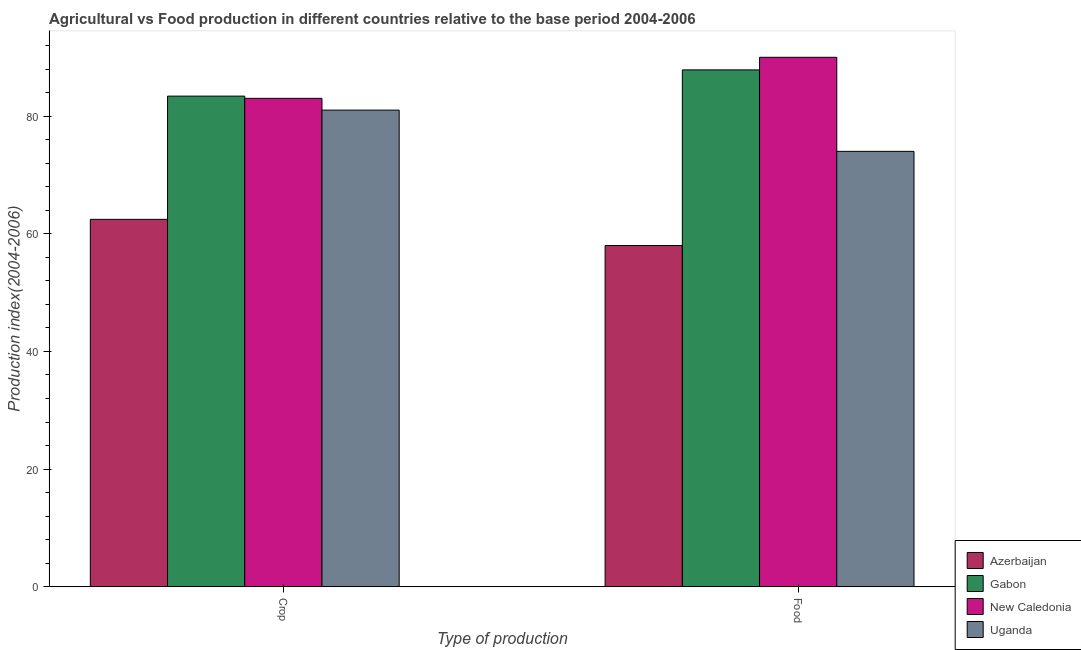What is the label of the 1st group of bars from the left?
Offer a very short reply. Crop. What is the crop production index in Azerbaijan?
Ensure brevity in your answer.  62.46. Across all countries, what is the maximum food production index?
Your answer should be compact. 90.01. Across all countries, what is the minimum crop production index?
Provide a succinct answer. 62.46. In which country was the crop production index maximum?
Provide a succinct answer. Gabon. In which country was the crop production index minimum?
Provide a succinct answer. Azerbaijan. What is the total crop production index in the graph?
Your answer should be very brief. 309.93. What is the difference between the crop production index in New Caledonia and that in Azerbaijan?
Your answer should be compact. 20.57. What is the difference between the crop production index in Azerbaijan and the food production index in Gabon?
Offer a very short reply. -25.41. What is the average food production index per country?
Your answer should be very brief. 77.48. What is the difference between the crop production index and food production index in New Caledonia?
Provide a short and direct response. -6.98. In how many countries, is the crop production index greater than 8 ?
Offer a terse response. 4. What is the ratio of the food production index in New Caledonia to that in Gabon?
Make the answer very short. 1.02. What does the 2nd bar from the left in Crop represents?
Make the answer very short. Gabon. What does the 1st bar from the right in Food represents?
Keep it short and to the point. Uganda. How many countries are there in the graph?
Offer a very short reply. 4. What is the difference between two consecutive major ticks on the Y-axis?
Offer a terse response. 20. Where does the legend appear in the graph?
Offer a terse response. Bottom right. What is the title of the graph?
Provide a short and direct response. Agricultural vs Food production in different countries relative to the base period 2004-2006. What is the label or title of the X-axis?
Offer a terse response. Type of production. What is the label or title of the Y-axis?
Offer a very short reply. Production index(2004-2006). What is the Production index(2004-2006) in Azerbaijan in Crop?
Make the answer very short. 62.46. What is the Production index(2004-2006) in Gabon in Crop?
Offer a terse response. 83.41. What is the Production index(2004-2006) of New Caledonia in Crop?
Your response must be concise. 83.03. What is the Production index(2004-2006) in Uganda in Crop?
Offer a terse response. 81.03. What is the Production index(2004-2006) of Azerbaijan in Food?
Keep it short and to the point. 58.01. What is the Production index(2004-2006) of Gabon in Food?
Offer a terse response. 87.87. What is the Production index(2004-2006) of New Caledonia in Food?
Keep it short and to the point. 90.01. What is the Production index(2004-2006) of Uganda in Food?
Make the answer very short. 74.02. Across all Type of production, what is the maximum Production index(2004-2006) of Azerbaijan?
Your response must be concise. 62.46. Across all Type of production, what is the maximum Production index(2004-2006) of Gabon?
Your answer should be compact. 87.87. Across all Type of production, what is the maximum Production index(2004-2006) of New Caledonia?
Provide a succinct answer. 90.01. Across all Type of production, what is the maximum Production index(2004-2006) of Uganda?
Provide a short and direct response. 81.03. Across all Type of production, what is the minimum Production index(2004-2006) in Azerbaijan?
Offer a terse response. 58.01. Across all Type of production, what is the minimum Production index(2004-2006) in Gabon?
Make the answer very short. 83.41. Across all Type of production, what is the minimum Production index(2004-2006) in New Caledonia?
Your answer should be compact. 83.03. Across all Type of production, what is the minimum Production index(2004-2006) in Uganda?
Your answer should be very brief. 74.02. What is the total Production index(2004-2006) of Azerbaijan in the graph?
Provide a succinct answer. 120.47. What is the total Production index(2004-2006) of Gabon in the graph?
Offer a very short reply. 171.28. What is the total Production index(2004-2006) of New Caledonia in the graph?
Provide a succinct answer. 173.04. What is the total Production index(2004-2006) in Uganda in the graph?
Your response must be concise. 155.05. What is the difference between the Production index(2004-2006) of Azerbaijan in Crop and that in Food?
Make the answer very short. 4.45. What is the difference between the Production index(2004-2006) in Gabon in Crop and that in Food?
Give a very brief answer. -4.46. What is the difference between the Production index(2004-2006) in New Caledonia in Crop and that in Food?
Your response must be concise. -6.98. What is the difference between the Production index(2004-2006) of Uganda in Crop and that in Food?
Your answer should be very brief. 7.01. What is the difference between the Production index(2004-2006) of Azerbaijan in Crop and the Production index(2004-2006) of Gabon in Food?
Give a very brief answer. -25.41. What is the difference between the Production index(2004-2006) of Azerbaijan in Crop and the Production index(2004-2006) of New Caledonia in Food?
Your response must be concise. -27.55. What is the difference between the Production index(2004-2006) of Azerbaijan in Crop and the Production index(2004-2006) of Uganda in Food?
Provide a succinct answer. -11.56. What is the difference between the Production index(2004-2006) of Gabon in Crop and the Production index(2004-2006) of New Caledonia in Food?
Your response must be concise. -6.6. What is the difference between the Production index(2004-2006) in Gabon in Crop and the Production index(2004-2006) in Uganda in Food?
Offer a terse response. 9.39. What is the difference between the Production index(2004-2006) in New Caledonia in Crop and the Production index(2004-2006) in Uganda in Food?
Ensure brevity in your answer.  9.01. What is the average Production index(2004-2006) in Azerbaijan per Type of production?
Ensure brevity in your answer.  60.23. What is the average Production index(2004-2006) in Gabon per Type of production?
Keep it short and to the point. 85.64. What is the average Production index(2004-2006) in New Caledonia per Type of production?
Provide a succinct answer. 86.52. What is the average Production index(2004-2006) of Uganda per Type of production?
Give a very brief answer. 77.53. What is the difference between the Production index(2004-2006) in Azerbaijan and Production index(2004-2006) in Gabon in Crop?
Offer a very short reply. -20.95. What is the difference between the Production index(2004-2006) of Azerbaijan and Production index(2004-2006) of New Caledonia in Crop?
Your answer should be compact. -20.57. What is the difference between the Production index(2004-2006) of Azerbaijan and Production index(2004-2006) of Uganda in Crop?
Your answer should be very brief. -18.57. What is the difference between the Production index(2004-2006) of Gabon and Production index(2004-2006) of New Caledonia in Crop?
Offer a very short reply. 0.38. What is the difference between the Production index(2004-2006) of Gabon and Production index(2004-2006) of Uganda in Crop?
Give a very brief answer. 2.38. What is the difference between the Production index(2004-2006) in Azerbaijan and Production index(2004-2006) in Gabon in Food?
Offer a very short reply. -29.86. What is the difference between the Production index(2004-2006) in Azerbaijan and Production index(2004-2006) in New Caledonia in Food?
Keep it short and to the point. -32. What is the difference between the Production index(2004-2006) of Azerbaijan and Production index(2004-2006) of Uganda in Food?
Offer a terse response. -16.01. What is the difference between the Production index(2004-2006) in Gabon and Production index(2004-2006) in New Caledonia in Food?
Offer a terse response. -2.14. What is the difference between the Production index(2004-2006) in Gabon and Production index(2004-2006) in Uganda in Food?
Provide a succinct answer. 13.85. What is the difference between the Production index(2004-2006) of New Caledonia and Production index(2004-2006) of Uganda in Food?
Give a very brief answer. 15.99. What is the ratio of the Production index(2004-2006) of Azerbaijan in Crop to that in Food?
Give a very brief answer. 1.08. What is the ratio of the Production index(2004-2006) of Gabon in Crop to that in Food?
Offer a terse response. 0.95. What is the ratio of the Production index(2004-2006) in New Caledonia in Crop to that in Food?
Ensure brevity in your answer.  0.92. What is the ratio of the Production index(2004-2006) of Uganda in Crop to that in Food?
Your answer should be very brief. 1.09. What is the difference between the highest and the second highest Production index(2004-2006) of Azerbaijan?
Ensure brevity in your answer.  4.45. What is the difference between the highest and the second highest Production index(2004-2006) in Gabon?
Your response must be concise. 4.46. What is the difference between the highest and the second highest Production index(2004-2006) of New Caledonia?
Make the answer very short. 6.98. What is the difference between the highest and the second highest Production index(2004-2006) in Uganda?
Keep it short and to the point. 7.01. What is the difference between the highest and the lowest Production index(2004-2006) of Azerbaijan?
Make the answer very short. 4.45. What is the difference between the highest and the lowest Production index(2004-2006) in Gabon?
Your answer should be compact. 4.46. What is the difference between the highest and the lowest Production index(2004-2006) of New Caledonia?
Provide a succinct answer. 6.98. What is the difference between the highest and the lowest Production index(2004-2006) of Uganda?
Give a very brief answer. 7.01. 